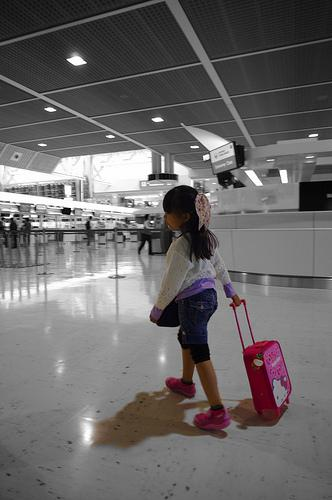Question: what color are the girl's shoes?
Choices:
A. Black.
B. Pink.
C. White.
D. Brown.
Answer with the letter. Answer: B Question: who is pulling her luggage?
Choices:
A. The boy.
B. The man.
C. The flight attendant.
D. The girl.
Answer with the letter. Answer: D Question: what color is the luggage?
Choices:
A. Black.
B. Pink and Red.
C. Red.
D. White.
Answer with the letter. Answer: B 